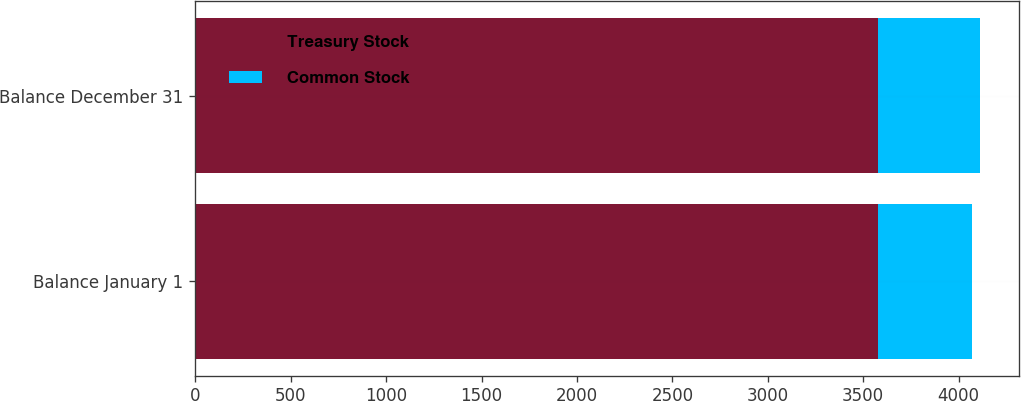<chart> <loc_0><loc_0><loc_500><loc_500><stacked_bar_chart><ecel><fcel>Balance January 1<fcel>Balance December 31<nl><fcel>Treasury Stock<fcel>3577<fcel>3577<nl><fcel>Common Stock<fcel>495<fcel>536<nl></chart> 